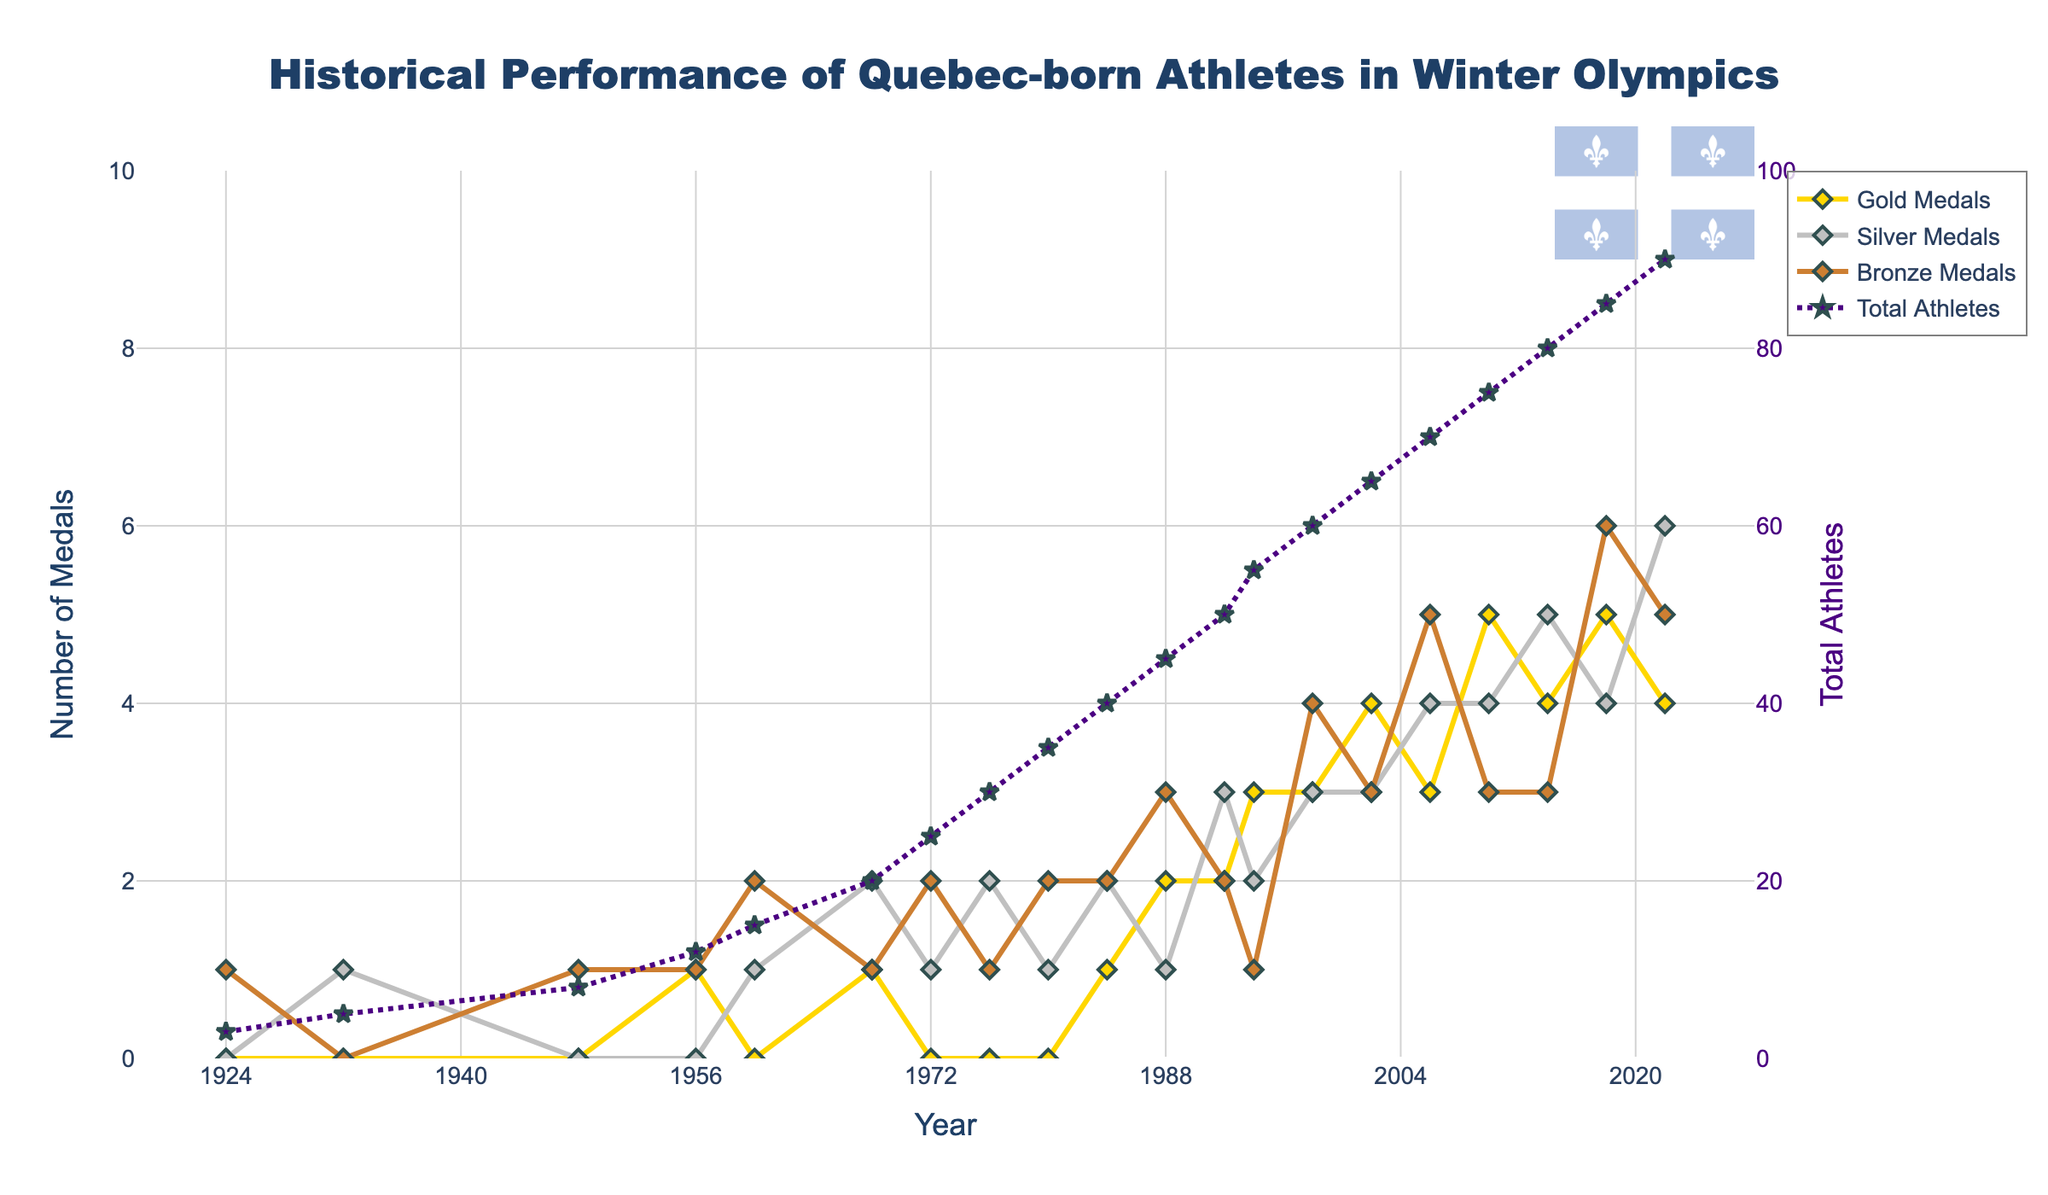Which year did Quebec-born athletes win the most medals? To determine the year with the most total medals, sum up the gold, silver, and bronze medals for each year and identify the year with the highest sum. The year 2018 has the highest sum: 5 (Gold) + 4 (Silver) + 6 (Bronze) = 15 medals.
Answer: 2018 How many fewer athletes participated in 1924 compared to 1956? Subtract the number of athletes in 1924 from the number of athletes in 1956: 12 - 3 = 9 fewer athletes.
Answer: 9 Which type of medal saw the highest increase between 2002 and 2010? Compare the number of each medal type in 2002 and 2010: Gold went from 4 to 5 (+1), Silver from 3 to 4 (+1), and Bronze from 3 to 3 (0). Therefore, Gold and Silver both saw the highest increase of +1.
Answer: Gold and Silver In which year did Quebec-born athletes win exactly one gold medal and more than two silver medals? Identify the year where Gold Medals = 1 and Silver Medals > 2. In 1968, the athletes won 1 Gold and 2 Silver medals. Therefore, there's no exact match. Recheck reveals years with 1 Gold and 2 Silver don't meet criteria.
Answer: None What is the median number of total athletes over the observed years? To find the median, list the total athletes in ascending order and find the middle value. The total athletes sorted: [3, 5, 8, 12, 15, 20, 25, 30, 35, 40, 45, 50, 55, 60, 65, 70, 75, 80, 85, 90]. Median is the average of the 10th and 11th values (40+45)/2 = 42.5
Answer: 42.5 Comparing 1960 and 1972, which year saw more total medals? Calculate the sum of medals in both years: 1960 = 0 (Gold) + 1 (Silver) + 2 (Bronze) = 3; 1972 = 0 (Gold) + 1 (Silver) + 2 (Bronze) = 3. Both years saw the same number of total medals.
Answer: Same Which color represents silver medals in the plot? Look at the visual elements in the plot and identify the line color associated with Silver Medals. Silver Medals trace is represented by the color silver.
Answer: Silver What is the total number of bronze medals won by Quebec-born athletes between 1948 and 1994? Sum the Bronze medals won in these years: 1948 (1) + 1956 (1) + 1960 (2) + 1968 (1) + 1972 (2) + 1976 (1) + 1980 (2) + 1984 (2) + 1988 (3) + 1992 (2) + 1994 (1) = 18
Answer: 18 What pattern can be seen in the total number of athletes from 1924 to 2022? Observe the "Total Athletes" trace on the graph. Overall, there's a consistent increase every year, with the total number of athletes rising from 3 in 1924 to 90 in 2022.
Answer: Consistent increase 